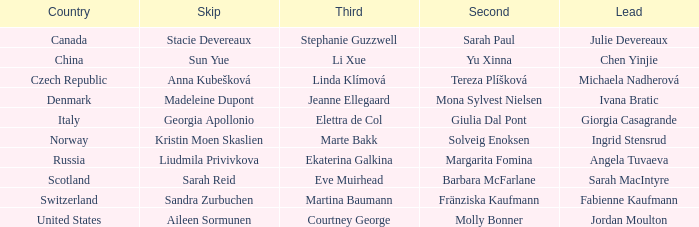Give me the full table as a dictionary. {'header': ['Country', 'Skip', 'Third', 'Second', 'Lead'], 'rows': [['Canada', 'Stacie Devereaux', 'Stephanie Guzzwell', 'Sarah Paul', 'Julie Devereaux'], ['China', 'Sun Yue', 'Li Xue', 'Yu Xinna', 'Chen Yinjie'], ['Czech Republic', 'Anna Kubešková', 'Linda Klímová', 'Tereza Plíšková', 'Michaela Nadherová'], ['Denmark', 'Madeleine Dupont', 'Jeanne Ellegaard', 'Mona Sylvest Nielsen', 'Ivana Bratic'], ['Italy', 'Georgia Apollonio', 'Elettra de Col', 'Giulia Dal Pont', 'Giorgia Casagrande'], ['Norway', 'Kristin Moen Skaslien', 'Marte Bakk', 'Solveig Enoksen', 'Ingrid Stensrud'], ['Russia', 'Liudmila Privivkova', 'Ekaterina Galkina', 'Margarita Fomina', 'Angela Tuvaeva'], ['Scotland', 'Sarah Reid', 'Eve Muirhead', 'Barbara McFarlane', 'Sarah MacIntyre'], ['Switzerland', 'Sandra Zurbuchen', 'Martina Baumann', 'Fränziska Kaufmann', 'Fabienne Kaufmann'], ['United States', 'Aileen Sormunen', 'Courtney George', 'Molly Bonner', 'Jordan Moulton']]} What skip has norway as the country? Kristin Moen Skaslien. 